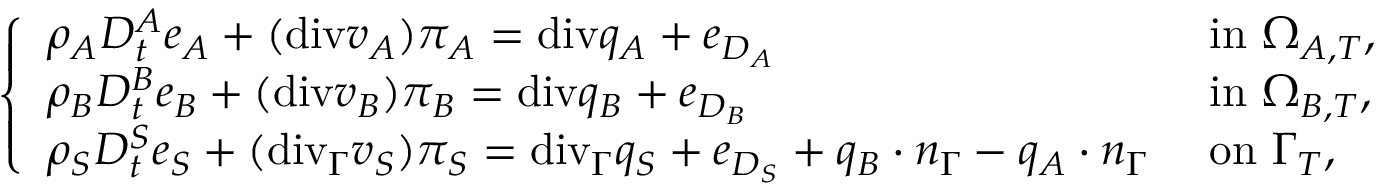<formula> <loc_0><loc_0><loc_500><loc_500>\left \{ \begin{array} { l l } { \rho _ { A } D _ { t } ^ { A } e _ { A } + ( { d i v } v _ { A } ) \pi _ { A } = { d i v } q _ { A } + e _ { D _ { A } } } & { i n \Omega _ { A , T } , } \\ { \rho _ { B } D _ { t } ^ { B } e _ { B } + ( { d i v } v _ { B } ) \pi _ { B } = { d i v } q _ { B } + e _ { D _ { B } } } & { i n \Omega _ { B , T } , } \\ { \rho _ { S } D _ { t } ^ { S } e _ { S } + ( { d i v } _ { \Gamma } v _ { S } ) \pi _ { S } = { d i v } _ { \Gamma } q _ { S } + e _ { D _ { S } } + q _ { B } \cdot n _ { \Gamma } - q _ { A } \cdot n _ { \Gamma } } & { o n \Gamma _ { T } , } \end{array}</formula> 